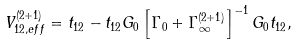Convert formula to latex. <formula><loc_0><loc_0><loc_500><loc_500>V ^ { ( 2 + 1 ) } _ { 1 2 , e f f } = t _ { 1 2 } - t _ { 1 2 } G _ { 0 } \left [ \Gamma _ { 0 } + \Gamma ^ { ( 2 + 1 ) } _ { \infty } \right ] ^ { - 1 } G _ { 0 } t _ { 1 2 } ,</formula> 